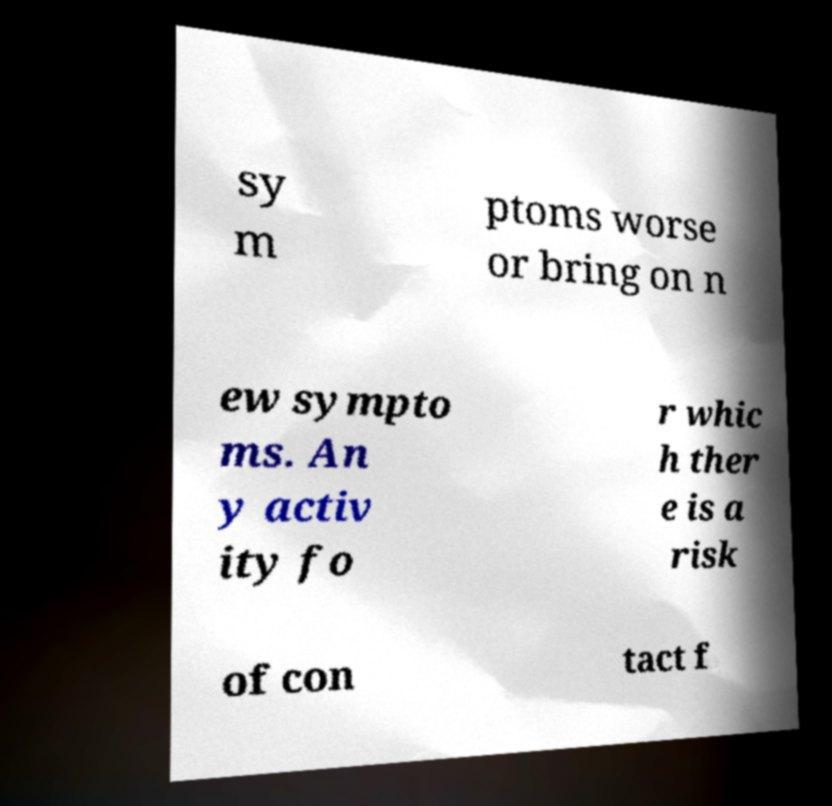Could you extract and type out the text from this image? sy m ptoms worse or bring on n ew sympto ms. An y activ ity fo r whic h ther e is a risk of con tact f 